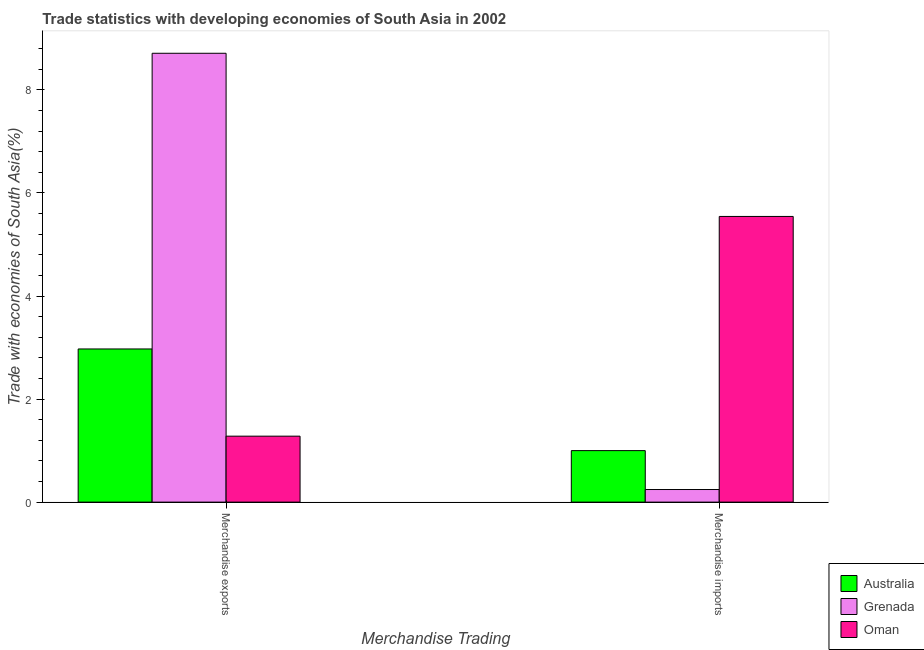How many different coloured bars are there?
Your answer should be very brief. 3. How many groups of bars are there?
Ensure brevity in your answer.  2. How many bars are there on the 1st tick from the left?
Keep it short and to the point. 3. What is the merchandise exports in Oman?
Your answer should be compact. 1.28. Across all countries, what is the maximum merchandise imports?
Offer a terse response. 5.54. Across all countries, what is the minimum merchandise imports?
Your answer should be compact. 0.24. In which country was the merchandise exports maximum?
Offer a terse response. Grenada. In which country was the merchandise exports minimum?
Your answer should be compact. Oman. What is the total merchandise imports in the graph?
Your response must be concise. 6.79. What is the difference between the merchandise imports in Oman and that in Grenada?
Your answer should be very brief. 5.3. What is the difference between the merchandise imports in Oman and the merchandise exports in Grenada?
Make the answer very short. -3.17. What is the average merchandise exports per country?
Provide a succinct answer. 4.32. What is the difference between the merchandise imports and merchandise exports in Grenada?
Give a very brief answer. -8.47. In how many countries, is the merchandise exports greater than 1.2000000000000002 %?
Provide a short and direct response. 3. What is the ratio of the merchandise imports in Oman to that in Grenada?
Your answer should be very brief. 22.66. Is the merchandise exports in Grenada less than that in Australia?
Keep it short and to the point. No. In how many countries, is the merchandise exports greater than the average merchandise exports taken over all countries?
Give a very brief answer. 1. What does the 2nd bar from the left in Merchandise exports represents?
Ensure brevity in your answer.  Grenada. What does the 1st bar from the right in Merchandise exports represents?
Provide a succinct answer. Oman. How many bars are there?
Offer a very short reply. 6. How many countries are there in the graph?
Give a very brief answer. 3. Are the values on the major ticks of Y-axis written in scientific E-notation?
Your response must be concise. No. Does the graph contain any zero values?
Ensure brevity in your answer.  No. Does the graph contain grids?
Provide a succinct answer. No. How many legend labels are there?
Ensure brevity in your answer.  3. How are the legend labels stacked?
Provide a succinct answer. Vertical. What is the title of the graph?
Your response must be concise. Trade statistics with developing economies of South Asia in 2002. Does "Cote d'Ivoire" appear as one of the legend labels in the graph?
Ensure brevity in your answer.  No. What is the label or title of the X-axis?
Provide a short and direct response. Merchandise Trading. What is the label or title of the Y-axis?
Ensure brevity in your answer.  Trade with economies of South Asia(%). What is the Trade with economies of South Asia(%) in Australia in Merchandise exports?
Provide a succinct answer. 2.97. What is the Trade with economies of South Asia(%) of Grenada in Merchandise exports?
Your answer should be very brief. 8.71. What is the Trade with economies of South Asia(%) of Oman in Merchandise exports?
Provide a short and direct response. 1.28. What is the Trade with economies of South Asia(%) in Australia in Merchandise imports?
Provide a short and direct response. 1. What is the Trade with economies of South Asia(%) of Grenada in Merchandise imports?
Offer a very short reply. 0.24. What is the Trade with economies of South Asia(%) of Oman in Merchandise imports?
Ensure brevity in your answer.  5.54. Across all Merchandise Trading, what is the maximum Trade with economies of South Asia(%) of Australia?
Make the answer very short. 2.97. Across all Merchandise Trading, what is the maximum Trade with economies of South Asia(%) in Grenada?
Make the answer very short. 8.71. Across all Merchandise Trading, what is the maximum Trade with economies of South Asia(%) in Oman?
Keep it short and to the point. 5.54. Across all Merchandise Trading, what is the minimum Trade with economies of South Asia(%) in Australia?
Provide a succinct answer. 1. Across all Merchandise Trading, what is the minimum Trade with economies of South Asia(%) of Grenada?
Your response must be concise. 0.24. Across all Merchandise Trading, what is the minimum Trade with economies of South Asia(%) of Oman?
Ensure brevity in your answer.  1.28. What is the total Trade with economies of South Asia(%) of Australia in the graph?
Ensure brevity in your answer.  3.97. What is the total Trade with economies of South Asia(%) of Grenada in the graph?
Your response must be concise. 8.96. What is the total Trade with economies of South Asia(%) of Oman in the graph?
Your answer should be compact. 6.82. What is the difference between the Trade with economies of South Asia(%) of Australia in Merchandise exports and that in Merchandise imports?
Provide a succinct answer. 1.97. What is the difference between the Trade with economies of South Asia(%) in Grenada in Merchandise exports and that in Merchandise imports?
Give a very brief answer. 8.47. What is the difference between the Trade with economies of South Asia(%) of Oman in Merchandise exports and that in Merchandise imports?
Offer a terse response. -4.26. What is the difference between the Trade with economies of South Asia(%) of Australia in Merchandise exports and the Trade with economies of South Asia(%) of Grenada in Merchandise imports?
Keep it short and to the point. 2.73. What is the difference between the Trade with economies of South Asia(%) in Australia in Merchandise exports and the Trade with economies of South Asia(%) in Oman in Merchandise imports?
Your response must be concise. -2.57. What is the difference between the Trade with economies of South Asia(%) of Grenada in Merchandise exports and the Trade with economies of South Asia(%) of Oman in Merchandise imports?
Ensure brevity in your answer.  3.17. What is the average Trade with economies of South Asia(%) of Australia per Merchandise Trading?
Your answer should be very brief. 1.99. What is the average Trade with economies of South Asia(%) in Grenada per Merchandise Trading?
Make the answer very short. 4.48. What is the average Trade with economies of South Asia(%) in Oman per Merchandise Trading?
Provide a succinct answer. 3.41. What is the difference between the Trade with economies of South Asia(%) of Australia and Trade with economies of South Asia(%) of Grenada in Merchandise exports?
Offer a terse response. -5.74. What is the difference between the Trade with economies of South Asia(%) in Australia and Trade with economies of South Asia(%) in Oman in Merchandise exports?
Make the answer very short. 1.69. What is the difference between the Trade with economies of South Asia(%) in Grenada and Trade with economies of South Asia(%) in Oman in Merchandise exports?
Your response must be concise. 7.43. What is the difference between the Trade with economies of South Asia(%) of Australia and Trade with economies of South Asia(%) of Grenada in Merchandise imports?
Keep it short and to the point. 0.76. What is the difference between the Trade with economies of South Asia(%) of Australia and Trade with economies of South Asia(%) of Oman in Merchandise imports?
Make the answer very short. -4.54. What is the difference between the Trade with economies of South Asia(%) of Grenada and Trade with economies of South Asia(%) of Oman in Merchandise imports?
Your answer should be very brief. -5.3. What is the ratio of the Trade with economies of South Asia(%) of Australia in Merchandise exports to that in Merchandise imports?
Provide a short and direct response. 2.97. What is the ratio of the Trade with economies of South Asia(%) in Grenada in Merchandise exports to that in Merchandise imports?
Offer a terse response. 35.61. What is the ratio of the Trade with economies of South Asia(%) in Oman in Merchandise exports to that in Merchandise imports?
Provide a succinct answer. 0.23. What is the difference between the highest and the second highest Trade with economies of South Asia(%) of Australia?
Keep it short and to the point. 1.97. What is the difference between the highest and the second highest Trade with economies of South Asia(%) in Grenada?
Offer a very short reply. 8.47. What is the difference between the highest and the second highest Trade with economies of South Asia(%) in Oman?
Your answer should be very brief. 4.26. What is the difference between the highest and the lowest Trade with economies of South Asia(%) in Australia?
Your answer should be very brief. 1.97. What is the difference between the highest and the lowest Trade with economies of South Asia(%) of Grenada?
Keep it short and to the point. 8.47. What is the difference between the highest and the lowest Trade with economies of South Asia(%) in Oman?
Offer a very short reply. 4.26. 